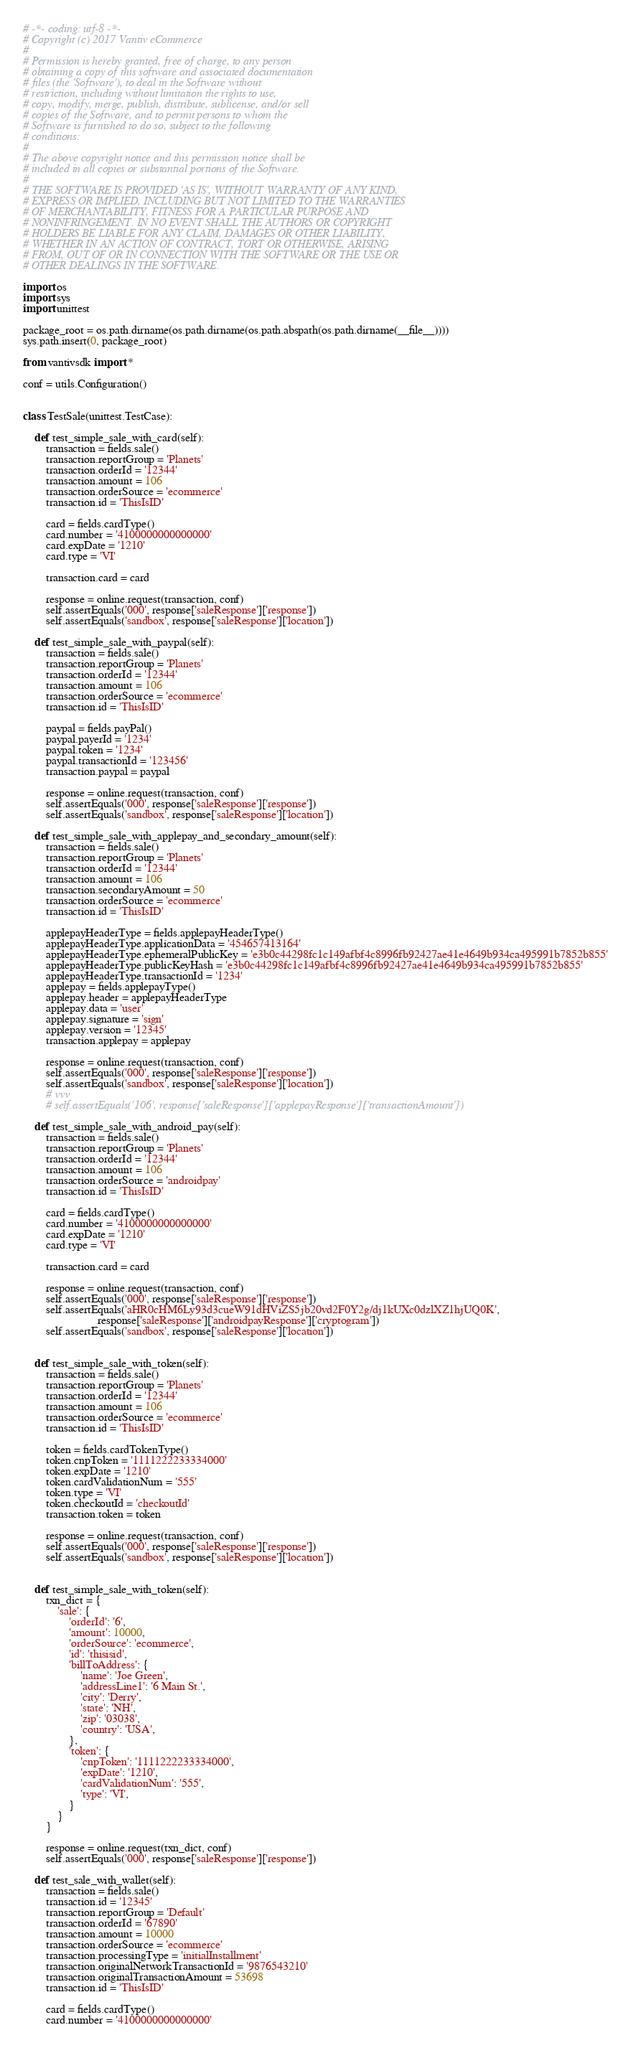<code> <loc_0><loc_0><loc_500><loc_500><_Python_># -*- coding: utf-8 -*-
# Copyright (c) 2017 Vantiv eCommerce
#
# Permission is hereby granted, free of charge, to any person
# obtaining a copy of this software and associated documentation
# files (the 'Software'), to deal in the Software without
# restriction, including without limitation the rights to use,
# copy, modify, merge, publish, distribute, sublicense, and/or sell
# copies of the Software, and to permit persons to whom the
# Software is furnished to do so, subject to the following
# conditions:
#
# The above copyright notice and this permission notice shall be
# included in all copies or substantial portions of the Software.
#
# THE SOFTWARE IS PROVIDED 'AS IS', WITHOUT WARRANTY OF ANY KIND,
# EXPRESS OR IMPLIED, INCLUDING BUT NOT LIMITED TO THE WARRANTIES
# OF MERCHANTABILITY, FITNESS FOR A PARTICULAR PURPOSE AND
# NONINFRINGEMENT. IN NO EVENT SHALL THE AUTHORS OR COPYRIGHT
# HOLDERS BE LIABLE FOR ANY CLAIM, DAMAGES OR OTHER LIABILITY,
# WHETHER IN AN ACTION OF CONTRACT, TORT OR OTHERWISE, ARISING
# FROM, OUT OF OR IN CONNECTION WITH THE SOFTWARE OR THE USE OR
# OTHER DEALINGS IN THE SOFTWARE.

import os
import sys
import unittest

package_root = os.path.dirname(os.path.dirname(os.path.abspath(os.path.dirname(__file__))))
sys.path.insert(0, package_root)

from vantivsdk import *

conf = utils.Configuration()


class TestSale(unittest.TestCase):

    def test_simple_sale_with_card(self):
        transaction = fields.sale()
        transaction.reportGroup = 'Planets'
        transaction.orderId = '12344'
        transaction.amount = 106
        transaction.orderSource = 'ecommerce'
        transaction.id = 'ThisIsID'

        card = fields.cardType()
        card.number = '4100000000000000'
        card.expDate = '1210'
        card.type = 'VI'

        transaction.card = card

        response = online.request(transaction, conf)
        self.assertEquals('000', response['saleResponse']['response'])
        self.assertEquals('sandbox', response['saleResponse']['location'])

    def test_simple_sale_with_paypal(self):
        transaction = fields.sale()
        transaction.reportGroup = 'Planets'
        transaction.orderId = '12344'
        transaction.amount = 106
        transaction.orderSource = 'ecommerce'
        transaction.id = 'ThisIsID'

        paypal = fields.payPal()
        paypal.payerId = '1234'
        paypal.token = '1234'
        paypal.transactionId = '123456'
        transaction.paypal = paypal

        response = online.request(transaction, conf)
        self.assertEquals('000', response['saleResponse']['response'])
        self.assertEquals('sandbox', response['saleResponse']['location'])

    def test_simple_sale_with_applepay_and_secondary_amount(self):
        transaction = fields.sale()
        transaction.reportGroup = 'Planets'
        transaction.orderId = '12344'
        transaction.amount = 106
        transaction.secondaryAmount = 50
        transaction.orderSource = 'ecommerce'
        transaction.id = 'ThisIsID'

        applepayHeaderType = fields.applepayHeaderType()
        applepayHeaderType.applicationData = '454657413164'
        applepayHeaderType.ephemeralPublicKey = 'e3b0c44298fc1c149afbf4c8996fb92427ae41e4649b934ca495991b7852b855'
        applepayHeaderType.publicKeyHash = 'e3b0c44298fc1c149afbf4c8996fb92427ae41e4649b934ca495991b7852b855'
        applepayHeaderType.transactionId = '1234'
        applepay = fields.applepayType()
        applepay.header = applepayHeaderType
        applepay.data = 'user'
        applepay.signature = 'sign'
        applepay.version = '12345'
        transaction.applepay = applepay

        response = online.request(transaction, conf)
        self.assertEquals('000', response['saleResponse']['response'])
        self.assertEquals('sandbox', response['saleResponse']['location'])
        # vvv
        # self.assertEquals('106', response['saleResponse']['applepayResponse']['transactionAmount'])

    def test_simple_sale_with_android_pay(self):
        transaction = fields.sale()
        transaction.reportGroup = 'Planets'
        transaction.orderId = '12344'
        transaction.amount = 106
        transaction.orderSource = 'androidpay'
        transaction.id = 'ThisIsID'

        card = fields.cardType()
        card.number = '4100000000000000'
        card.expDate = '1210'
        card.type = 'VI'

        transaction.card = card

        response = online.request(transaction, conf)
        self.assertEquals('000', response['saleResponse']['response'])
        self.assertEquals('aHR0cHM6Ly93d3cueW91dHViZS5jb20vd2F0Y2g/dj1kUXc0dzlXZ1hjUQ0K',
                          response['saleResponse']['androidpayResponse']['cryptogram'])
        self.assertEquals('sandbox', response['saleResponse']['location'])


    def test_simple_sale_with_token(self):
        transaction = fields.sale()
        transaction.reportGroup = 'Planets'
        transaction.orderId = '12344'
        transaction.amount = 106
        transaction.orderSource = 'ecommerce'
        transaction.id = 'ThisIsID'

        token = fields.cardTokenType()
        token.cnpToken = '1111222233334000'
        token.expDate = '1210'
        token.cardValidationNum = '555'
        token.type = 'VI'
        token.checkoutId = 'checkoutId'
        transaction.token = token

        response = online.request(transaction, conf)
        self.assertEquals('000', response['saleResponse']['response'])
        self.assertEquals('sandbox', response['saleResponse']['location'])


    def test_simple_sale_with_token(self):
        txn_dict = {
            'sale': {
                'orderId': '6',
                'amount': 10000,
                'orderSource': 'ecommerce',
                'id': 'thisisid',
                'billToAddress': {
                    'name': 'Joe Green',
                    'addressLine1': '6 Main St.',
                    'city': 'Derry',
                    'state': 'NH',
                    'zip': '03038',
                    'country': 'USA',
                },
                'token': {
                    'cnpToken': '1111222233334000',
                    'expDate': '1210',
                    'cardValidationNum': '555',
                    'type': 'VI',
                }
            }
        }

        response = online.request(txn_dict, conf)
        self.assertEquals('000', response['saleResponse']['response'])

    def test_sale_with_wallet(self):
        transaction = fields.sale()
        transaction.id = '12345'
        transaction.reportGroup = 'Default'
        transaction.orderId = '67890'
        transaction.amount = 10000
        transaction.orderSource = 'ecommerce'
        transaction.processingType = 'initialInstallment'
        transaction.originalNetworkTransactionId = '9876543210'
        transaction.originalTransactionAmount = 53698
        transaction.id = 'ThisIsID'

        card = fields.cardType()
        card.number = '4100000000000000'</code> 